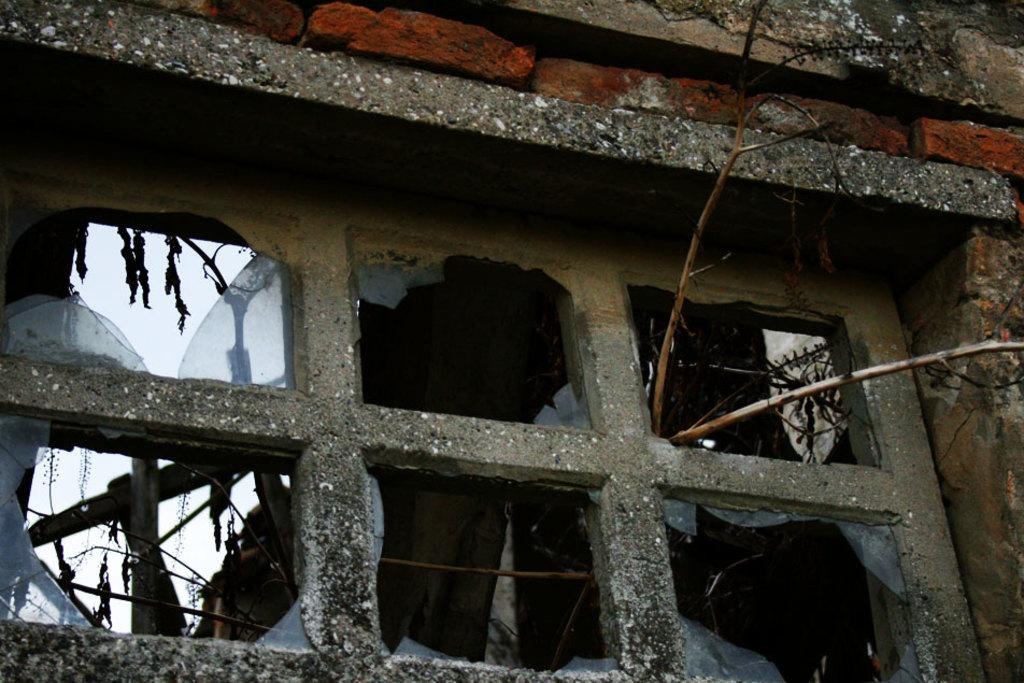What is the condition of the window glass doors in the image? The window glass doors are broken in the image. What objects can be seen on the ground in the image? There are sticks visible in the image. What type of structure is present in the background of the image? There is a brick wall in the image. How many pies are floating on the boat in the image? There is no boat or pies present in the image. What is the highest point in the image? The image does not have a specific point that can be identified as the highest; it is a flat representation of the scene. 